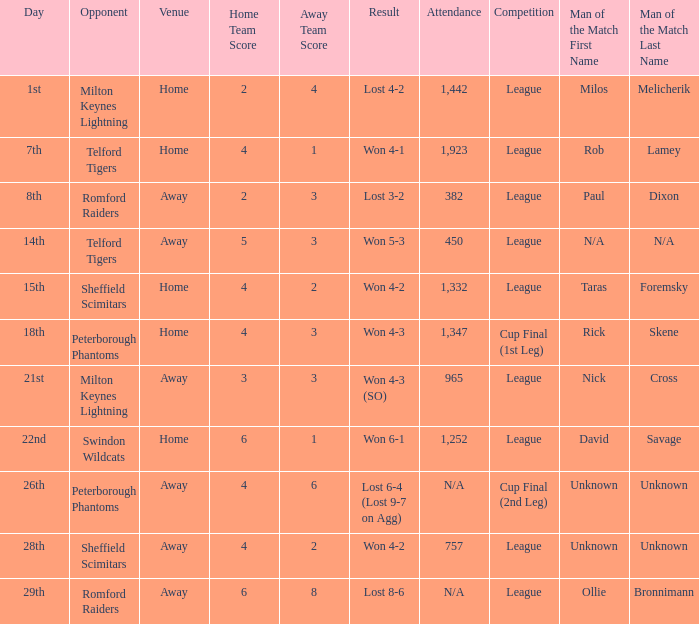Who was the Man of the Match when the opponent was Milton Keynes Lightning and the venue was Away? Nick Cross. 